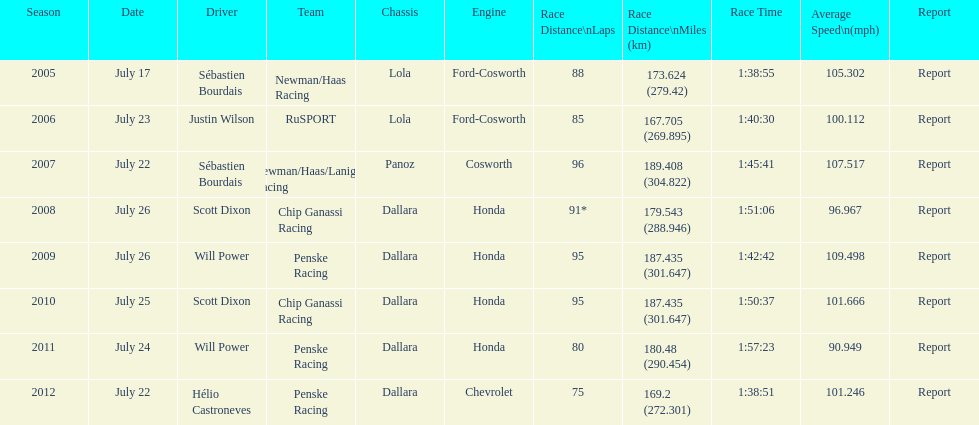Can you parse all the data within this table? {'header': ['Season', 'Date', 'Driver', 'Team', 'Chassis', 'Engine', 'Race Distance\\nLaps', 'Race Distance\\nMiles (km)', 'Race Time', 'Average Speed\\n(mph)', 'Report'], 'rows': [['2005', 'July 17', 'Sébastien Bourdais', 'Newman/Haas Racing', 'Lola', 'Ford-Cosworth', '88', '173.624 (279.42)', '1:38:55', '105.302', 'Report'], ['2006', 'July 23', 'Justin Wilson', 'RuSPORT', 'Lola', 'Ford-Cosworth', '85', '167.705 (269.895)', '1:40:30', '100.112', 'Report'], ['2007', 'July 22', 'Sébastien Bourdais', 'Newman/Haas/Lanigan Racing', 'Panoz', 'Cosworth', '96', '189.408 (304.822)', '1:45:41', '107.517', 'Report'], ['2008', 'July 26', 'Scott Dixon', 'Chip Ganassi Racing', 'Dallara', 'Honda', '91*', '179.543 (288.946)', '1:51:06', '96.967', 'Report'], ['2009', 'July 26', 'Will Power', 'Penske Racing', 'Dallara', 'Honda', '95', '187.435 (301.647)', '1:42:42', '109.498', 'Report'], ['2010', 'July 25', 'Scott Dixon', 'Chip Ganassi Racing', 'Dallara', 'Honda', '95', '187.435 (301.647)', '1:50:37', '101.666', 'Report'], ['2011', 'July 24', 'Will Power', 'Penske Racing', 'Dallara', 'Honda', '80', '180.48 (290.454)', '1:57:23', '90.949', 'Report'], ['2012', 'July 22', 'Hélio Castroneves', 'Penske Racing', 'Dallara', 'Chevrolet', '75', '169.2 (272.301)', '1:38:51', '101.246', 'Report']]} In 2011, was the mean speed of the indycar series higher or lower than the mean speed in the preceding year? Below. 